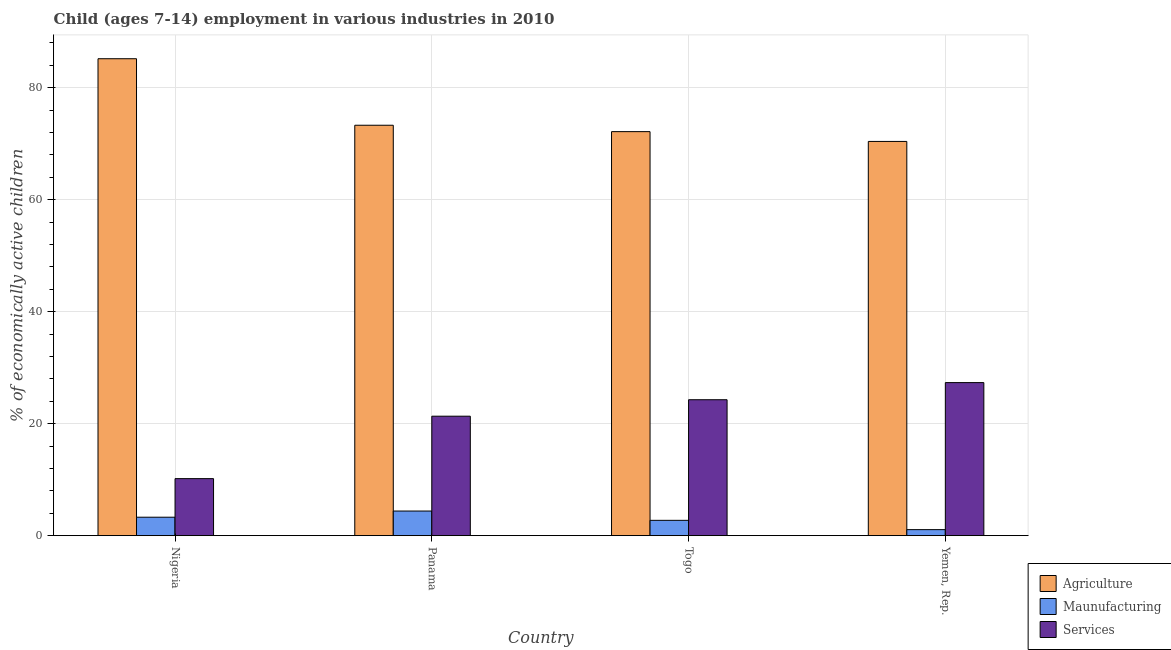How many different coloured bars are there?
Your answer should be compact. 3. How many groups of bars are there?
Give a very brief answer. 4. Are the number of bars on each tick of the X-axis equal?
Offer a terse response. Yes. How many bars are there on the 1st tick from the left?
Your answer should be compact. 3. What is the label of the 1st group of bars from the left?
Your answer should be very brief. Nigeria. What is the percentage of economically active children in manufacturing in Panama?
Your answer should be very brief. 4.4. In which country was the percentage of economically active children in agriculture maximum?
Your response must be concise. Nigeria. In which country was the percentage of economically active children in agriculture minimum?
Provide a short and direct response. Yemen, Rep. What is the total percentage of economically active children in agriculture in the graph?
Provide a short and direct response. 301.05. What is the difference between the percentage of economically active children in agriculture in Nigeria and that in Panama?
Keep it short and to the point. 11.88. What is the difference between the percentage of economically active children in manufacturing in Yemen, Rep. and the percentage of economically active children in agriculture in Panama?
Your response must be concise. -72.22. What is the average percentage of economically active children in services per country?
Make the answer very short. 20.79. What is the difference between the percentage of economically active children in manufacturing and percentage of economically active children in services in Yemen, Rep.?
Provide a short and direct response. -26.26. In how many countries, is the percentage of economically active children in services greater than 80 %?
Give a very brief answer. 0. What is the ratio of the percentage of economically active children in manufacturing in Panama to that in Yemen, Rep.?
Provide a short and direct response. 4.07. What is the difference between the highest and the second highest percentage of economically active children in services?
Keep it short and to the point. 3.06. What is the difference between the highest and the lowest percentage of economically active children in manufacturing?
Make the answer very short. 3.32. In how many countries, is the percentage of economically active children in manufacturing greater than the average percentage of economically active children in manufacturing taken over all countries?
Your answer should be compact. 2. Is the sum of the percentage of economically active children in manufacturing in Panama and Togo greater than the maximum percentage of economically active children in agriculture across all countries?
Your answer should be very brief. No. What does the 2nd bar from the left in Nigeria represents?
Provide a succinct answer. Maunufacturing. What does the 3rd bar from the right in Yemen, Rep. represents?
Keep it short and to the point. Agriculture. Where does the legend appear in the graph?
Your response must be concise. Bottom right. How many legend labels are there?
Provide a short and direct response. 3. How are the legend labels stacked?
Offer a terse response. Vertical. What is the title of the graph?
Make the answer very short. Child (ages 7-14) employment in various industries in 2010. Does "Financial account" appear as one of the legend labels in the graph?
Provide a succinct answer. No. What is the label or title of the X-axis?
Make the answer very short. Country. What is the label or title of the Y-axis?
Your answer should be compact. % of economically active children. What is the % of economically active children in Agriculture in Nigeria?
Offer a very short reply. 85.18. What is the % of economically active children in Services in Nigeria?
Keep it short and to the point. 10.19. What is the % of economically active children in Agriculture in Panama?
Provide a succinct answer. 73.3. What is the % of economically active children in Services in Panama?
Ensure brevity in your answer.  21.34. What is the % of economically active children in Agriculture in Togo?
Ensure brevity in your answer.  72.16. What is the % of economically active children of Maunufacturing in Togo?
Ensure brevity in your answer.  2.74. What is the % of economically active children of Services in Togo?
Ensure brevity in your answer.  24.28. What is the % of economically active children in Agriculture in Yemen, Rep.?
Give a very brief answer. 70.41. What is the % of economically active children of Maunufacturing in Yemen, Rep.?
Provide a short and direct response. 1.08. What is the % of economically active children of Services in Yemen, Rep.?
Keep it short and to the point. 27.34. Across all countries, what is the maximum % of economically active children in Agriculture?
Offer a terse response. 85.18. Across all countries, what is the maximum % of economically active children in Maunufacturing?
Make the answer very short. 4.4. Across all countries, what is the maximum % of economically active children of Services?
Ensure brevity in your answer.  27.34. Across all countries, what is the minimum % of economically active children in Agriculture?
Give a very brief answer. 70.41. Across all countries, what is the minimum % of economically active children of Services?
Your answer should be compact. 10.19. What is the total % of economically active children of Agriculture in the graph?
Your answer should be compact. 301.05. What is the total % of economically active children in Maunufacturing in the graph?
Your answer should be compact. 11.52. What is the total % of economically active children in Services in the graph?
Your answer should be compact. 83.15. What is the difference between the % of economically active children in Agriculture in Nigeria and that in Panama?
Make the answer very short. 11.88. What is the difference between the % of economically active children in Maunufacturing in Nigeria and that in Panama?
Ensure brevity in your answer.  -1.1. What is the difference between the % of economically active children in Services in Nigeria and that in Panama?
Give a very brief answer. -11.15. What is the difference between the % of economically active children of Agriculture in Nigeria and that in Togo?
Ensure brevity in your answer.  13.02. What is the difference between the % of economically active children in Maunufacturing in Nigeria and that in Togo?
Keep it short and to the point. 0.56. What is the difference between the % of economically active children in Services in Nigeria and that in Togo?
Keep it short and to the point. -14.09. What is the difference between the % of economically active children of Agriculture in Nigeria and that in Yemen, Rep.?
Your response must be concise. 14.77. What is the difference between the % of economically active children in Maunufacturing in Nigeria and that in Yemen, Rep.?
Ensure brevity in your answer.  2.22. What is the difference between the % of economically active children in Services in Nigeria and that in Yemen, Rep.?
Your answer should be compact. -17.15. What is the difference between the % of economically active children in Agriculture in Panama and that in Togo?
Your response must be concise. 1.14. What is the difference between the % of economically active children in Maunufacturing in Panama and that in Togo?
Your answer should be compact. 1.66. What is the difference between the % of economically active children in Services in Panama and that in Togo?
Offer a very short reply. -2.94. What is the difference between the % of economically active children of Agriculture in Panama and that in Yemen, Rep.?
Provide a succinct answer. 2.89. What is the difference between the % of economically active children in Maunufacturing in Panama and that in Yemen, Rep.?
Your answer should be very brief. 3.32. What is the difference between the % of economically active children of Services in Panama and that in Yemen, Rep.?
Your answer should be very brief. -6. What is the difference between the % of economically active children of Agriculture in Togo and that in Yemen, Rep.?
Offer a very short reply. 1.75. What is the difference between the % of economically active children in Maunufacturing in Togo and that in Yemen, Rep.?
Offer a terse response. 1.66. What is the difference between the % of economically active children in Services in Togo and that in Yemen, Rep.?
Your answer should be very brief. -3.06. What is the difference between the % of economically active children of Agriculture in Nigeria and the % of economically active children of Maunufacturing in Panama?
Provide a succinct answer. 80.78. What is the difference between the % of economically active children in Agriculture in Nigeria and the % of economically active children in Services in Panama?
Offer a very short reply. 63.84. What is the difference between the % of economically active children of Maunufacturing in Nigeria and the % of economically active children of Services in Panama?
Keep it short and to the point. -18.04. What is the difference between the % of economically active children in Agriculture in Nigeria and the % of economically active children in Maunufacturing in Togo?
Keep it short and to the point. 82.44. What is the difference between the % of economically active children of Agriculture in Nigeria and the % of economically active children of Services in Togo?
Ensure brevity in your answer.  60.9. What is the difference between the % of economically active children in Maunufacturing in Nigeria and the % of economically active children in Services in Togo?
Offer a terse response. -20.98. What is the difference between the % of economically active children of Agriculture in Nigeria and the % of economically active children of Maunufacturing in Yemen, Rep.?
Give a very brief answer. 84.1. What is the difference between the % of economically active children in Agriculture in Nigeria and the % of economically active children in Services in Yemen, Rep.?
Keep it short and to the point. 57.84. What is the difference between the % of economically active children of Maunufacturing in Nigeria and the % of economically active children of Services in Yemen, Rep.?
Keep it short and to the point. -24.04. What is the difference between the % of economically active children in Agriculture in Panama and the % of economically active children in Maunufacturing in Togo?
Provide a short and direct response. 70.56. What is the difference between the % of economically active children of Agriculture in Panama and the % of economically active children of Services in Togo?
Give a very brief answer. 49.02. What is the difference between the % of economically active children in Maunufacturing in Panama and the % of economically active children in Services in Togo?
Provide a short and direct response. -19.88. What is the difference between the % of economically active children of Agriculture in Panama and the % of economically active children of Maunufacturing in Yemen, Rep.?
Your answer should be very brief. 72.22. What is the difference between the % of economically active children of Agriculture in Panama and the % of economically active children of Services in Yemen, Rep.?
Offer a very short reply. 45.96. What is the difference between the % of economically active children of Maunufacturing in Panama and the % of economically active children of Services in Yemen, Rep.?
Give a very brief answer. -22.94. What is the difference between the % of economically active children of Agriculture in Togo and the % of economically active children of Maunufacturing in Yemen, Rep.?
Give a very brief answer. 71.08. What is the difference between the % of economically active children of Agriculture in Togo and the % of economically active children of Services in Yemen, Rep.?
Offer a terse response. 44.82. What is the difference between the % of economically active children in Maunufacturing in Togo and the % of economically active children in Services in Yemen, Rep.?
Make the answer very short. -24.6. What is the average % of economically active children in Agriculture per country?
Give a very brief answer. 75.26. What is the average % of economically active children of Maunufacturing per country?
Keep it short and to the point. 2.88. What is the average % of economically active children of Services per country?
Your answer should be very brief. 20.79. What is the difference between the % of economically active children of Agriculture and % of economically active children of Maunufacturing in Nigeria?
Provide a succinct answer. 81.88. What is the difference between the % of economically active children in Agriculture and % of economically active children in Services in Nigeria?
Your response must be concise. 74.99. What is the difference between the % of economically active children in Maunufacturing and % of economically active children in Services in Nigeria?
Offer a terse response. -6.89. What is the difference between the % of economically active children of Agriculture and % of economically active children of Maunufacturing in Panama?
Keep it short and to the point. 68.9. What is the difference between the % of economically active children of Agriculture and % of economically active children of Services in Panama?
Offer a very short reply. 51.96. What is the difference between the % of economically active children in Maunufacturing and % of economically active children in Services in Panama?
Ensure brevity in your answer.  -16.94. What is the difference between the % of economically active children of Agriculture and % of economically active children of Maunufacturing in Togo?
Provide a succinct answer. 69.42. What is the difference between the % of economically active children of Agriculture and % of economically active children of Services in Togo?
Give a very brief answer. 47.88. What is the difference between the % of economically active children of Maunufacturing and % of economically active children of Services in Togo?
Offer a very short reply. -21.54. What is the difference between the % of economically active children in Agriculture and % of economically active children in Maunufacturing in Yemen, Rep.?
Your answer should be very brief. 69.33. What is the difference between the % of economically active children in Agriculture and % of economically active children in Services in Yemen, Rep.?
Ensure brevity in your answer.  43.07. What is the difference between the % of economically active children in Maunufacturing and % of economically active children in Services in Yemen, Rep.?
Your answer should be compact. -26.26. What is the ratio of the % of economically active children in Agriculture in Nigeria to that in Panama?
Your answer should be compact. 1.16. What is the ratio of the % of economically active children of Services in Nigeria to that in Panama?
Your response must be concise. 0.48. What is the ratio of the % of economically active children in Agriculture in Nigeria to that in Togo?
Your answer should be very brief. 1.18. What is the ratio of the % of economically active children of Maunufacturing in Nigeria to that in Togo?
Keep it short and to the point. 1.2. What is the ratio of the % of economically active children in Services in Nigeria to that in Togo?
Ensure brevity in your answer.  0.42. What is the ratio of the % of economically active children of Agriculture in Nigeria to that in Yemen, Rep.?
Offer a very short reply. 1.21. What is the ratio of the % of economically active children of Maunufacturing in Nigeria to that in Yemen, Rep.?
Give a very brief answer. 3.06. What is the ratio of the % of economically active children in Services in Nigeria to that in Yemen, Rep.?
Provide a succinct answer. 0.37. What is the ratio of the % of economically active children of Agriculture in Panama to that in Togo?
Offer a very short reply. 1.02. What is the ratio of the % of economically active children in Maunufacturing in Panama to that in Togo?
Offer a very short reply. 1.61. What is the ratio of the % of economically active children in Services in Panama to that in Togo?
Your answer should be compact. 0.88. What is the ratio of the % of economically active children in Agriculture in Panama to that in Yemen, Rep.?
Make the answer very short. 1.04. What is the ratio of the % of economically active children of Maunufacturing in Panama to that in Yemen, Rep.?
Ensure brevity in your answer.  4.07. What is the ratio of the % of economically active children in Services in Panama to that in Yemen, Rep.?
Offer a very short reply. 0.78. What is the ratio of the % of economically active children of Agriculture in Togo to that in Yemen, Rep.?
Offer a terse response. 1.02. What is the ratio of the % of economically active children of Maunufacturing in Togo to that in Yemen, Rep.?
Offer a very short reply. 2.54. What is the ratio of the % of economically active children in Services in Togo to that in Yemen, Rep.?
Provide a short and direct response. 0.89. What is the difference between the highest and the second highest % of economically active children of Agriculture?
Offer a terse response. 11.88. What is the difference between the highest and the second highest % of economically active children of Maunufacturing?
Offer a very short reply. 1.1. What is the difference between the highest and the second highest % of economically active children of Services?
Your answer should be very brief. 3.06. What is the difference between the highest and the lowest % of economically active children of Agriculture?
Your answer should be compact. 14.77. What is the difference between the highest and the lowest % of economically active children in Maunufacturing?
Provide a short and direct response. 3.32. What is the difference between the highest and the lowest % of economically active children in Services?
Your answer should be compact. 17.15. 